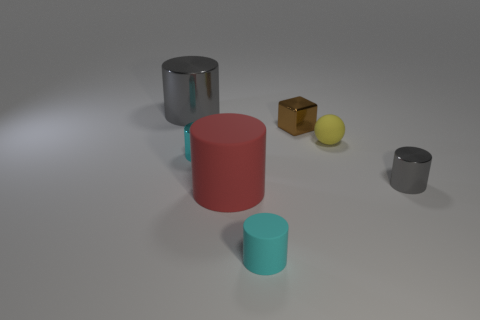Subtract all gray cylinders. How many were subtracted if there are1gray cylinders left? 1 Subtract all red cylinders. How many cylinders are left? 4 Subtract all tiny cyan rubber cylinders. How many cylinders are left? 4 Subtract all blue cylinders. Subtract all blue spheres. How many cylinders are left? 5 Add 3 small green matte objects. How many objects exist? 10 Subtract all spheres. How many objects are left? 6 Add 1 small yellow rubber objects. How many small yellow rubber objects exist? 2 Subtract 1 gray cylinders. How many objects are left? 6 Subtract all gray objects. Subtract all metal cylinders. How many objects are left? 2 Add 5 matte cylinders. How many matte cylinders are left? 7 